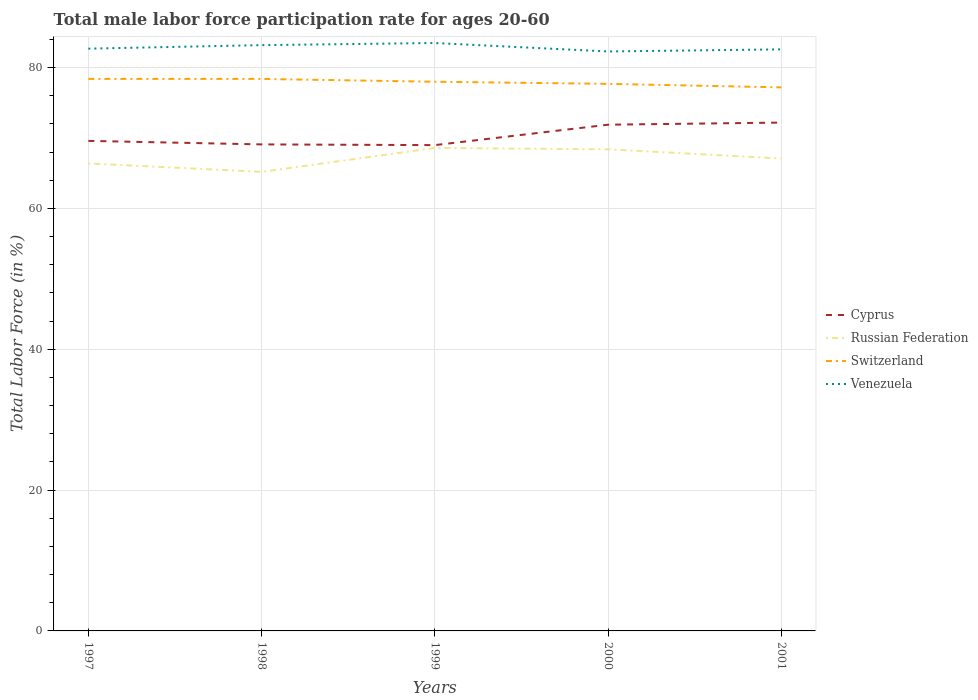Does the line corresponding to Venezuela intersect with the line corresponding to Switzerland?
Keep it short and to the point. No. Is the number of lines equal to the number of legend labels?
Offer a very short reply. Yes. Across all years, what is the maximum male labor force participation rate in Russian Federation?
Offer a very short reply. 65.2. What is the total male labor force participation rate in Russian Federation in the graph?
Your answer should be compact. 1.5. What is the difference between the highest and the second highest male labor force participation rate in Venezuela?
Offer a very short reply. 1.2. What is the difference between the highest and the lowest male labor force participation rate in Russian Federation?
Offer a very short reply. 2. Is the male labor force participation rate in Switzerland strictly greater than the male labor force participation rate in Venezuela over the years?
Your answer should be compact. Yes. How many lines are there?
Ensure brevity in your answer.  4. What is the difference between two consecutive major ticks on the Y-axis?
Your response must be concise. 20. Does the graph contain grids?
Give a very brief answer. Yes. How are the legend labels stacked?
Give a very brief answer. Vertical. What is the title of the graph?
Your answer should be very brief. Total male labor force participation rate for ages 20-60. Does "Bulgaria" appear as one of the legend labels in the graph?
Keep it short and to the point. No. What is the label or title of the Y-axis?
Give a very brief answer. Total Labor Force (in %). What is the Total Labor Force (in %) in Cyprus in 1997?
Give a very brief answer. 69.6. What is the Total Labor Force (in %) in Russian Federation in 1997?
Provide a succinct answer. 66.4. What is the Total Labor Force (in %) of Switzerland in 1997?
Offer a terse response. 78.4. What is the Total Labor Force (in %) in Venezuela in 1997?
Keep it short and to the point. 82.7. What is the Total Labor Force (in %) in Cyprus in 1998?
Offer a terse response. 69.1. What is the Total Labor Force (in %) in Russian Federation in 1998?
Ensure brevity in your answer.  65.2. What is the Total Labor Force (in %) of Switzerland in 1998?
Make the answer very short. 78.4. What is the Total Labor Force (in %) of Venezuela in 1998?
Your answer should be compact. 83.2. What is the Total Labor Force (in %) in Cyprus in 1999?
Ensure brevity in your answer.  69. What is the Total Labor Force (in %) of Russian Federation in 1999?
Provide a succinct answer. 68.6. What is the Total Labor Force (in %) in Switzerland in 1999?
Your answer should be very brief. 78. What is the Total Labor Force (in %) in Venezuela in 1999?
Provide a short and direct response. 83.5. What is the Total Labor Force (in %) of Cyprus in 2000?
Provide a succinct answer. 71.9. What is the Total Labor Force (in %) of Russian Federation in 2000?
Your answer should be very brief. 68.4. What is the Total Labor Force (in %) of Switzerland in 2000?
Offer a terse response. 77.7. What is the Total Labor Force (in %) of Venezuela in 2000?
Offer a terse response. 82.3. What is the Total Labor Force (in %) of Cyprus in 2001?
Make the answer very short. 72.2. What is the Total Labor Force (in %) of Russian Federation in 2001?
Your answer should be compact. 67.1. What is the Total Labor Force (in %) of Switzerland in 2001?
Keep it short and to the point. 77.2. What is the Total Labor Force (in %) of Venezuela in 2001?
Your answer should be very brief. 82.6. Across all years, what is the maximum Total Labor Force (in %) of Cyprus?
Ensure brevity in your answer.  72.2. Across all years, what is the maximum Total Labor Force (in %) in Russian Federation?
Provide a succinct answer. 68.6. Across all years, what is the maximum Total Labor Force (in %) in Switzerland?
Your answer should be very brief. 78.4. Across all years, what is the maximum Total Labor Force (in %) in Venezuela?
Provide a succinct answer. 83.5. Across all years, what is the minimum Total Labor Force (in %) of Russian Federation?
Your answer should be very brief. 65.2. Across all years, what is the minimum Total Labor Force (in %) of Switzerland?
Provide a short and direct response. 77.2. Across all years, what is the minimum Total Labor Force (in %) of Venezuela?
Keep it short and to the point. 82.3. What is the total Total Labor Force (in %) of Cyprus in the graph?
Give a very brief answer. 351.8. What is the total Total Labor Force (in %) of Russian Federation in the graph?
Give a very brief answer. 335.7. What is the total Total Labor Force (in %) of Switzerland in the graph?
Provide a short and direct response. 389.7. What is the total Total Labor Force (in %) in Venezuela in the graph?
Make the answer very short. 414.3. What is the difference between the Total Labor Force (in %) in Russian Federation in 1997 and that in 1998?
Your response must be concise. 1.2. What is the difference between the Total Labor Force (in %) of Venezuela in 1997 and that in 1998?
Ensure brevity in your answer.  -0.5. What is the difference between the Total Labor Force (in %) of Cyprus in 1997 and that in 1999?
Your answer should be compact. 0.6. What is the difference between the Total Labor Force (in %) of Venezuela in 1997 and that in 1999?
Ensure brevity in your answer.  -0.8. What is the difference between the Total Labor Force (in %) in Cyprus in 1997 and that in 2000?
Your answer should be compact. -2.3. What is the difference between the Total Labor Force (in %) in Russian Federation in 1997 and that in 2000?
Your response must be concise. -2. What is the difference between the Total Labor Force (in %) in Switzerland in 1997 and that in 2000?
Your answer should be very brief. 0.7. What is the difference between the Total Labor Force (in %) in Russian Federation in 1997 and that in 2001?
Make the answer very short. -0.7. What is the difference between the Total Labor Force (in %) in Russian Federation in 1998 and that in 1999?
Provide a short and direct response. -3.4. What is the difference between the Total Labor Force (in %) in Switzerland in 1998 and that in 1999?
Your answer should be compact. 0.4. What is the difference between the Total Labor Force (in %) of Cyprus in 1998 and that in 2000?
Offer a very short reply. -2.8. What is the difference between the Total Labor Force (in %) of Venezuela in 1998 and that in 2000?
Provide a short and direct response. 0.9. What is the difference between the Total Labor Force (in %) in Venezuela in 1998 and that in 2001?
Provide a short and direct response. 0.6. What is the difference between the Total Labor Force (in %) in Russian Federation in 1999 and that in 2000?
Offer a very short reply. 0.2. What is the difference between the Total Labor Force (in %) of Russian Federation in 1999 and that in 2001?
Make the answer very short. 1.5. What is the difference between the Total Labor Force (in %) in Cyprus in 2000 and that in 2001?
Your answer should be compact. -0.3. What is the difference between the Total Labor Force (in %) of Russian Federation in 2000 and that in 2001?
Your answer should be very brief. 1.3. What is the difference between the Total Labor Force (in %) in Cyprus in 1997 and the Total Labor Force (in %) in Russian Federation in 1998?
Keep it short and to the point. 4.4. What is the difference between the Total Labor Force (in %) of Cyprus in 1997 and the Total Labor Force (in %) of Switzerland in 1998?
Give a very brief answer. -8.8. What is the difference between the Total Labor Force (in %) in Russian Federation in 1997 and the Total Labor Force (in %) in Venezuela in 1998?
Offer a very short reply. -16.8. What is the difference between the Total Labor Force (in %) of Cyprus in 1997 and the Total Labor Force (in %) of Russian Federation in 1999?
Your answer should be compact. 1. What is the difference between the Total Labor Force (in %) of Cyprus in 1997 and the Total Labor Force (in %) of Venezuela in 1999?
Make the answer very short. -13.9. What is the difference between the Total Labor Force (in %) in Russian Federation in 1997 and the Total Labor Force (in %) in Switzerland in 1999?
Ensure brevity in your answer.  -11.6. What is the difference between the Total Labor Force (in %) of Russian Federation in 1997 and the Total Labor Force (in %) of Venezuela in 1999?
Provide a short and direct response. -17.1. What is the difference between the Total Labor Force (in %) in Switzerland in 1997 and the Total Labor Force (in %) in Venezuela in 1999?
Offer a very short reply. -5.1. What is the difference between the Total Labor Force (in %) of Cyprus in 1997 and the Total Labor Force (in %) of Venezuela in 2000?
Your answer should be compact. -12.7. What is the difference between the Total Labor Force (in %) in Russian Federation in 1997 and the Total Labor Force (in %) in Venezuela in 2000?
Provide a short and direct response. -15.9. What is the difference between the Total Labor Force (in %) in Switzerland in 1997 and the Total Labor Force (in %) in Venezuela in 2000?
Offer a terse response. -3.9. What is the difference between the Total Labor Force (in %) in Cyprus in 1997 and the Total Labor Force (in %) in Venezuela in 2001?
Give a very brief answer. -13. What is the difference between the Total Labor Force (in %) in Russian Federation in 1997 and the Total Labor Force (in %) in Switzerland in 2001?
Offer a very short reply. -10.8. What is the difference between the Total Labor Force (in %) of Russian Federation in 1997 and the Total Labor Force (in %) of Venezuela in 2001?
Offer a very short reply. -16.2. What is the difference between the Total Labor Force (in %) of Cyprus in 1998 and the Total Labor Force (in %) of Venezuela in 1999?
Keep it short and to the point. -14.4. What is the difference between the Total Labor Force (in %) in Russian Federation in 1998 and the Total Labor Force (in %) in Venezuela in 1999?
Ensure brevity in your answer.  -18.3. What is the difference between the Total Labor Force (in %) of Switzerland in 1998 and the Total Labor Force (in %) of Venezuela in 1999?
Offer a terse response. -5.1. What is the difference between the Total Labor Force (in %) of Cyprus in 1998 and the Total Labor Force (in %) of Russian Federation in 2000?
Offer a very short reply. 0.7. What is the difference between the Total Labor Force (in %) of Cyprus in 1998 and the Total Labor Force (in %) of Switzerland in 2000?
Provide a short and direct response. -8.6. What is the difference between the Total Labor Force (in %) of Russian Federation in 1998 and the Total Labor Force (in %) of Venezuela in 2000?
Offer a terse response. -17.1. What is the difference between the Total Labor Force (in %) in Cyprus in 1998 and the Total Labor Force (in %) in Russian Federation in 2001?
Provide a short and direct response. 2. What is the difference between the Total Labor Force (in %) in Russian Federation in 1998 and the Total Labor Force (in %) in Switzerland in 2001?
Your answer should be very brief. -12. What is the difference between the Total Labor Force (in %) of Russian Federation in 1998 and the Total Labor Force (in %) of Venezuela in 2001?
Ensure brevity in your answer.  -17.4. What is the difference between the Total Labor Force (in %) of Cyprus in 1999 and the Total Labor Force (in %) of Russian Federation in 2000?
Provide a short and direct response. 0.6. What is the difference between the Total Labor Force (in %) in Russian Federation in 1999 and the Total Labor Force (in %) in Venezuela in 2000?
Your answer should be very brief. -13.7. What is the difference between the Total Labor Force (in %) of Switzerland in 1999 and the Total Labor Force (in %) of Venezuela in 2000?
Give a very brief answer. -4.3. What is the difference between the Total Labor Force (in %) of Cyprus in 1999 and the Total Labor Force (in %) of Russian Federation in 2001?
Ensure brevity in your answer.  1.9. What is the difference between the Total Labor Force (in %) of Cyprus in 1999 and the Total Labor Force (in %) of Venezuela in 2001?
Provide a succinct answer. -13.6. What is the difference between the Total Labor Force (in %) of Russian Federation in 1999 and the Total Labor Force (in %) of Venezuela in 2001?
Provide a short and direct response. -14. What is the difference between the Total Labor Force (in %) in Switzerland in 1999 and the Total Labor Force (in %) in Venezuela in 2001?
Ensure brevity in your answer.  -4.6. What is the difference between the Total Labor Force (in %) of Cyprus in 2000 and the Total Labor Force (in %) of Russian Federation in 2001?
Provide a succinct answer. 4.8. What is the difference between the Total Labor Force (in %) in Russian Federation in 2000 and the Total Labor Force (in %) in Venezuela in 2001?
Provide a short and direct response. -14.2. What is the average Total Labor Force (in %) in Cyprus per year?
Make the answer very short. 70.36. What is the average Total Labor Force (in %) of Russian Federation per year?
Provide a succinct answer. 67.14. What is the average Total Labor Force (in %) of Switzerland per year?
Your response must be concise. 77.94. What is the average Total Labor Force (in %) in Venezuela per year?
Keep it short and to the point. 82.86. In the year 1997, what is the difference between the Total Labor Force (in %) in Cyprus and Total Labor Force (in %) in Russian Federation?
Give a very brief answer. 3.2. In the year 1997, what is the difference between the Total Labor Force (in %) in Cyprus and Total Labor Force (in %) in Switzerland?
Your answer should be very brief. -8.8. In the year 1997, what is the difference between the Total Labor Force (in %) in Russian Federation and Total Labor Force (in %) in Venezuela?
Give a very brief answer. -16.3. In the year 1997, what is the difference between the Total Labor Force (in %) in Switzerland and Total Labor Force (in %) in Venezuela?
Your answer should be compact. -4.3. In the year 1998, what is the difference between the Total Labor Force (in %) of Cyprus and Total Labor Force (in %) of Russian Federation?
Offer a very short reply. 3.9. In the year 1998, what is the difference between the Total Labor Force (in %) in Cyprus and Total Labor Force (in %) in Venezuela?
Provide a succinct answer. -14.1. In the year 1998, what is the difference between the Total Labor Force (in %) in Switzerland and Total Labor Force (in %) in Venezuela?
Ensure brevity in your answer.  -4.8. In the year 1999, what is the difference between the Total Labor Force (in %) in Cyprus and Total Labor Force (in %) in Venezuela?
Offer a terse response. -14.5. In the year 1999, what is the difference between the Total Labor Force (in %) of Russian Federation and Total Labor Force (in %) of Switzerland?
Your answer should be very brief. -9.4. In the year 1999, what is the difference between the Total Labor Force (in %) in Russian Federation and Total Labor Force (in %) in Venezuela?
Your answer should be very brief. -14.9. In the year 2000, what is the difference between the Total Labor Force (in %) in Cyprus and Total Labor Force (in %) in Russian Federation?
Ensure brevity in your answer.  3.5. In the year 2000, what is the difference between the Total Labor Force (in %) of Cyprus and Total Labor Force (in %) of Switzerland?
Your answer should be very brief. -5.8. In the year 2000, what is the difference between the Total Labor Force (in %) in Cyprus and Total Labor Force (in %) in Venezuela?
Keep it short and to the point. -10.4. In the year 2000, what is the difference between the Total Labor Force (in %) in Russian Federation and Total Labor Force (in %) in Switzerland?
Your answer should be compact. -9.3. In the year 2001, what is the difference between the Total Labor Force (in %) of Cyprus and Total Labor Force (in %) of Russian Federation?
Your response must be concise. 5.1. In the year 2001, what is the difference between the Total Labor Force (in %) in Cyprus and Total Labor Force (in %) in Switzerland?
Provide a short and direct response. -5. In the year 2001, what is the difference between the Total Labor Force (in %) in Russian Federation and Total Labor Force (in %) in Switzerland?
Provide a succinct answer. -10.1. In the year 2001, what is the difference between the Total Labor Force (in %) in Russian Federation and Total Labor Force (in %) in Venezuela?
Your answer should be compact. -15.5. What is the ratio of the Total Labor Force (in %) in Cyprus in 1997 to that in 1998?
Provide a short and direct response. 1.01. What is the ratio of the Total Labor Force (in %) of Russian Federation in 1997 to that in 1998?
Keep it short and to the point. 1.02. What is the ratio of the Total Labor Force (in %) in Switzerland in 1997 to that in 1998?
Provide a short and direct response. 1. What is the ratio of the Total Labor Force (in %) of Venezuela in 1997 to that in 1998?
Offer a very short reply. 0.99. What is the ratio of the Total Labor Force (in %) of Cyprus in 1997 to that in 1999?
Offer a terse response. 1.01. What is the ratio of the Total Labor Force (in %) of Russian Federation in 1997 to that in 1999?
Keep it short and to the point. 0.97. What is the ratio of the Total Labor Force (in %) in Switzerland in 1997 to that in 1999?
Ensure brevity in your answer.  1.01. What is the ratio of the Total Labor Force (in %) in Venezuela in 1997 to that in 1999?
Your answer should be very brief. 0.99. What is the ratio of the Total Labor Force (in %) in Russian Federation in 1997 to that in 2000?
Ensure brevity in your answer.  0.97. What is the ratio of the Total Labor Force (in %) in Switzerland in 1997 to that in 2000?
Offer a very short reply. 1.01. What is the ratio of the Total Labor Force (in %) in Venezuela in 1997 to that in 2000?
Make the answer very short. 1. What is the ratio of the Total Labor Force (in %) in Cyprus in 1997 to that in 2001?
Your answer should be compact. 0.96. What is the ratio of the Total Labor Force (in %) of Switzerland in 1997 to that in 2001?
Keep it short and to the point. 1.02. What is the ratio of the Total Labor Force (in %) in Venezuela in 1997 to that in 2001?
Your answer should be very brief. 1. What is the ratio of the Total Labor Force (in %) in Russian Federation in 1998 to that in 1999?
Provide a succinct answer. 0.95. What is the ratio of the Total Labor Force (in %) in Venezuela in 1998 to that in 1999?
Your answer should be compact. 1. What is the ratio of the Total Labor Force (in %) of Cyprus in 1998 to that in 2000?
Your answer should be very brief. 0.96. What is the ratio of the Total Labor Force (in %) of Russian Federation in 1998 to that in 2000?
Ensure brevity in your answer.  0.95. What is the ratio of the Total Labor Force (in %) in Venezuela in 1998 to that in 2000?
Your answer should be very brief. 1.01. What is the ratio of the Total Labor Force (in %) in Cyprus in 1998 to that in 2001?
Provide a succinct answer. 0.96. What is the ratio of the Total Labor Force (in %) of Russian Federation in 1998 to that in 2001?
Your answer should be compact. 0.97. What is the ratio of the Total Labor Force (in %) of Switzerland in 1998 to that in 2001?
Provide a succinct answer. 1.02. What is the ratio of the Total Labor Force (in %) of Venezuela in 1998 to that in 2001?
Give a very brief answer. 1.01. What is the ratio of the Total Labor Force (in %) in Cyprus in 1999 to that in 2000?
Make the answer very short. 0.96. What is the ratio of the Total Labor Force (in %) of Russian Federation in 1999 to that in 2000?
Your response must be concise. 1. What is the ratio of the Total Labor Force (in %) of Switzerland in 1999 to that in 2000?
Your answer should be very brief. 1. What is the ratio of the Total Labor Force (in %) in Venezuela in 1999 to that in 2000?
Your answer should be very brief. 1.01. What is the ratio of the Total Labor Force (in %) in Cyprus in 1999 to that in 2001?
Give a very brief answer. 0.96. What is the ratio of the Total Labor Force (in %) in Russian Federation in 1999 to that in 2001?
Give a very brief answer. 1.02. What is the ratio of the Total Labor Force (in %) of Switzerland in 1999 to that in 2001?
Ensure brevity in your answer.  1.01. What is the ratio of the Total Labor Force (in %) in Venezuela in 1999 to that in 2001?
Provide a short and direct response. 1.01. What is the ratio of the Total Labor Force (in %) of Cyprus in 2000 to that in 2001?
Your answer should be compact. 1. What is the ratio of the Total Labor Force (in %) in Russian Federation in 2000 to that in 2001?
Offer a terse response. 1.02. What is the ratio of the Total Labor Force (in %) in Switzerland in 2000 to that in 2001?
Keep it short and to the point. 1.01. What is the ratio of the Total Labor Force (in %) in Venezuela in 2000 to that in 2001?
Offer a terse response. 1. What is the difference between the highest and the lowest Total Labor Force (in %) of Cyprus?
Your answer should be compact. 3.2. What is the difference between the highest and the lowest Total Labor Force (in %) in Switzerland?
Your answer should be very brief. 1.2. 